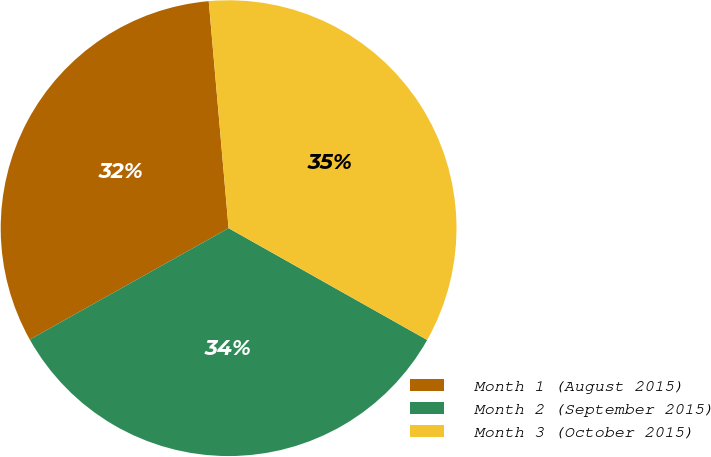Convert chart to OTSL. <chart><loc_0><loc_0><loc_500><loc_500><pie_chart><fcel>Month 1 (August 2015)<fcel>Month 2 (September 2015)<fcel>Month 3 (October 2015)<nl><fcel>31.74%<fcel>33.71%<fcel>34.55%<nl></chart> 